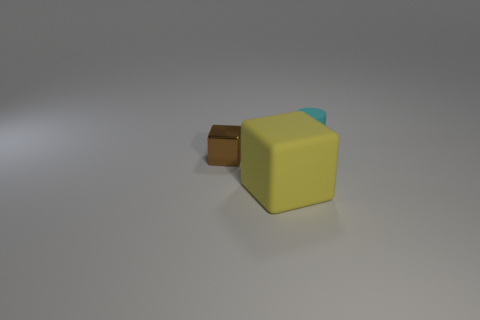Add 1 tiny matte objects. How many objects exist? 4 Subtract all cubes. How many objects are left? 1 Add 2 large cubes. How many large cubes are left? 3 Add 3 big brown cubes. How many big brown cubes exist? 3 Subtract 0 gray spheres. How many objects are left? 3 Subtract all shiny cubes. Subtract all cyan cylinders. How many objects are left? 1 